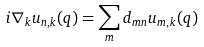<formula> <loc_0><loc_0><loc_500><loc_500>i \nabla _ { k } u _ { n , { k } } ( { q } ) = \sum _ { m } { d _ { m n } } u _ { m , { k } } ( { q } )</formula> 